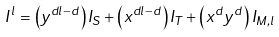Convert formula to latex. <formula><loc_0><loc_0><loc_500><loc_500>I ^ { l } = \left ( y ^ { d l - d } \right ) I _ { S } + \left ( x ^ { d l - d } \right ) I _ { T } + \left ( x ^ { d } y ^ { d } \right ) I _ { M , l }</formula> 